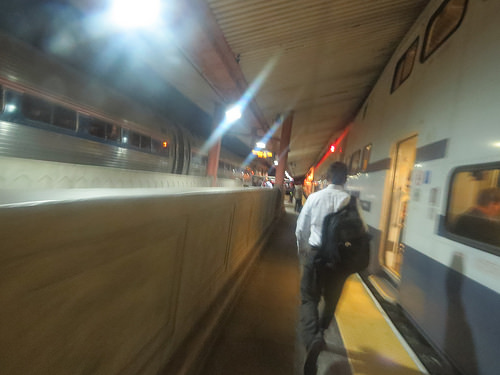<image>
Is there a person next to the subway? Yes. The person is positioned adjacent to the subway, located nearby in the same general area. 